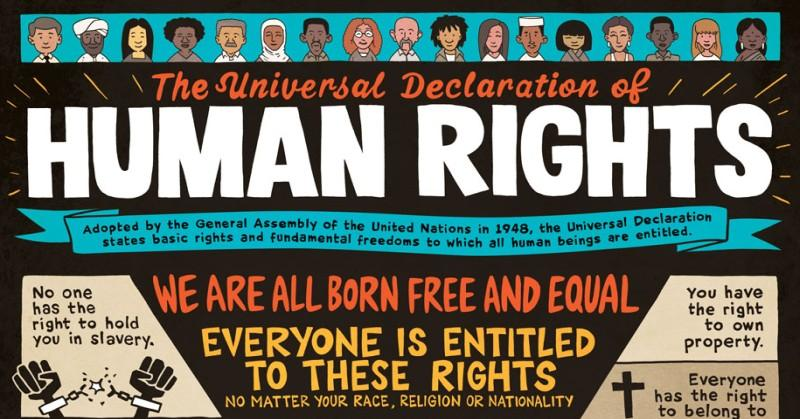Identify some key points in this picture. The Universal Declaration of Human Rights was adopted by the General Assembly of the United Nations in 1948. 